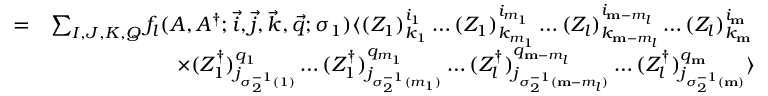Convert formula to latex. <formula><loc_0><loc_0><loc_500><loc_500>\begin{array} { r l } { = } & { \sum _ { I , J , K , Q } f _ { l } ( A , A ^ { \dagger } ; \vec { i } , \vec { j } , \vec { k } , \vec { q } ; \sigma _ { 1 } ) \langle ( Z _ { 1 } ) _ { k _ { 1 } } ^ { i _ { 1 } } \dots ( Z _ { 1 } ) _ { k _ { m _ { 1 } } } ^ { i _ { m _ { 1 } } } \dots ( Z _ { l } ) _ { k _ { m - m _ { l } } } ^ { i _ { m - m _ { l } } } \dots ( Z _ { l } ) _ { k _ { m } } ^ { i _ { m } } } \\ & { \quad \times ( Z _ { 1 } ^ { \dagger } ) _ { j _ { \sigma _ { 2 } ^ { - 1 } ( 1 ) } } ^ { q _ { 1 } } \dots ( Z _ { 1 } ^ { \dagger } ) _ { j _ { \sigma _ { 2 } ^ { - 1 } ( m _ { 1 } ) } } ^ { q _ { m _ { 1 } } } \dots ( Z _ { l } ^ { \dagger } ) _ { j _ { \sigma _ { 2 } ^ { - 1 } ( m - m _ { l } ) } } ^ { q _ { m - m _ { l } } } \dots ( Z _ { l } ^ { \dagger } ) _ { j _ { \sigma _ { 2 } ^ { - 1 } ( m ) } } ^ { q _ { m } } \rangle } \end{array}</formula> 